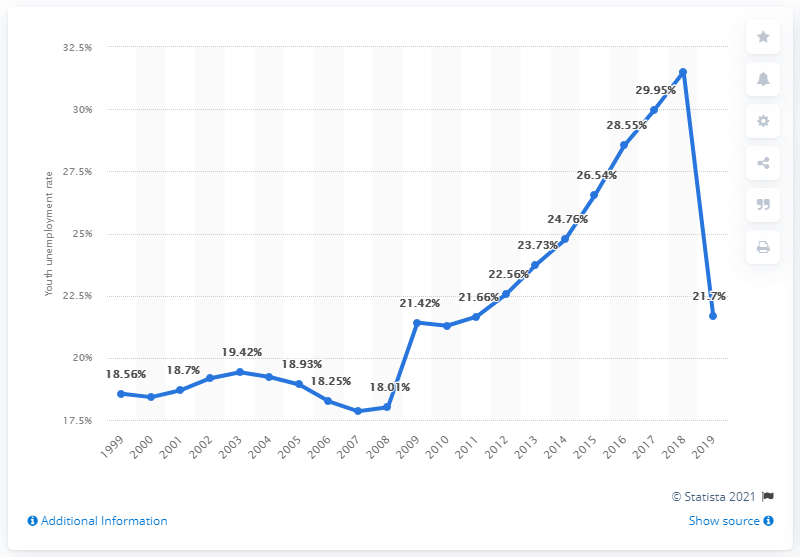Specify some key components in this picture. The youth unemployment rate in Brunei Darussalam in 2019 was 21.7%. 